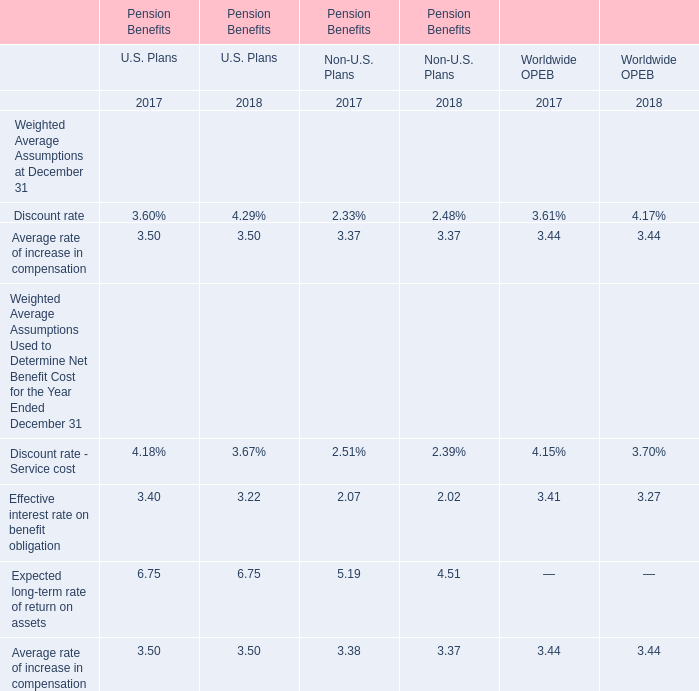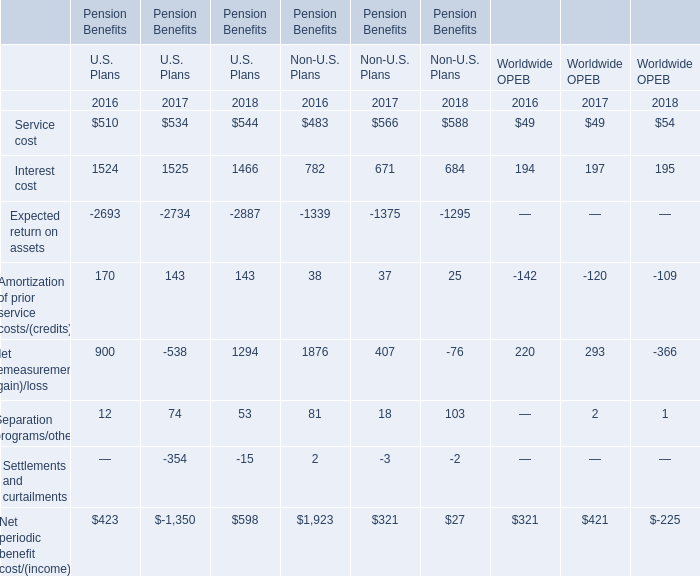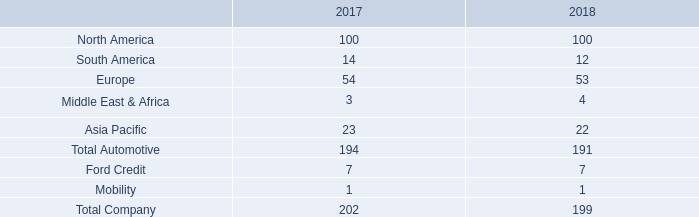What is the proportion of Service cost to the total in 2016 for U.S. Plans of Pension Benefits? 
Computations: (510 / (((((170 + 12) + 510) + 1524) - 2693) + 900))
Answer: 1.20567. 